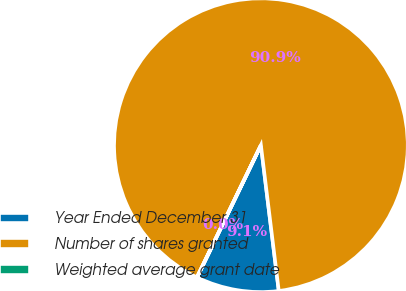Convert chart to OTSL. <chart><loc_0><loc_0><loc_500><loc_500><pie_chart><fcel>Year Ended December 31<fcel>Number of shares granted<fcel>Weighted average grant date<nl><fcel>9.1%<fcel>90.88%<fcel>0.02%<nl></chart> 